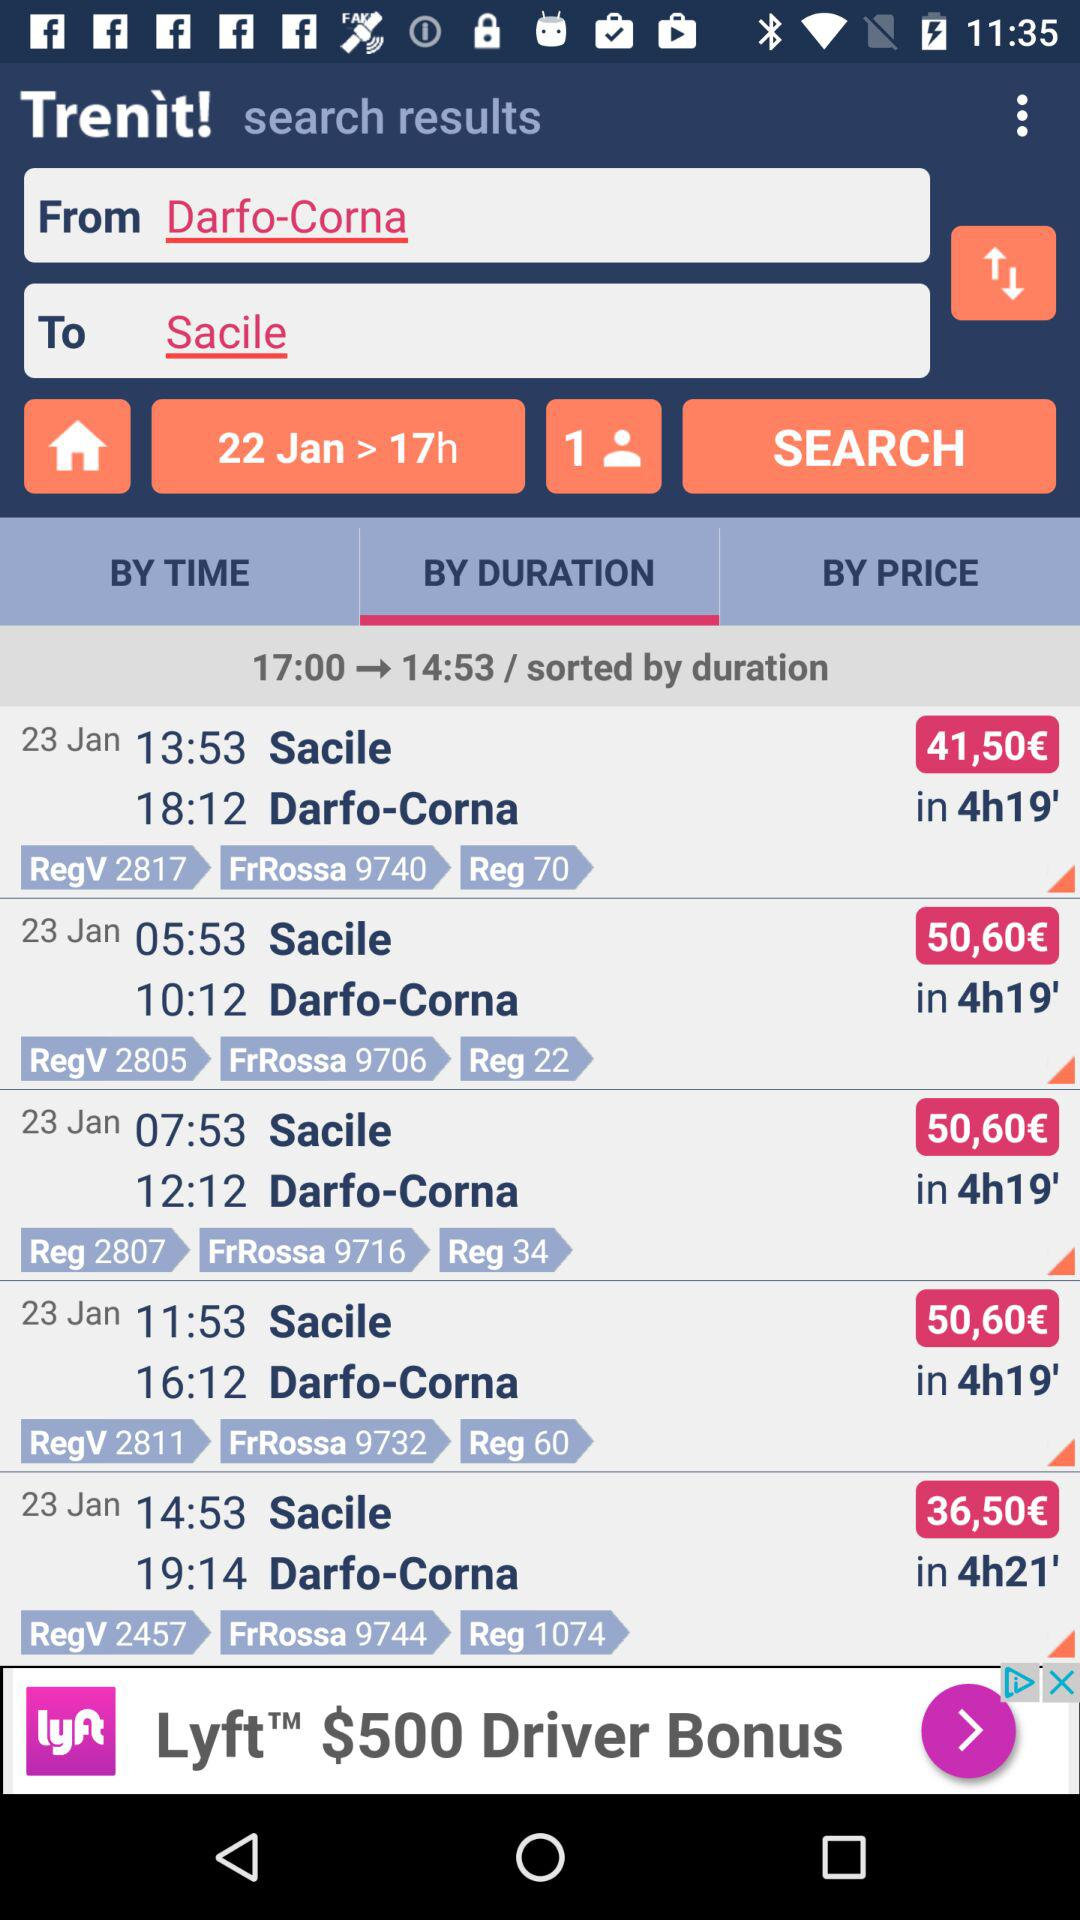What is the journey duration? The journey duration is 17 hours. 